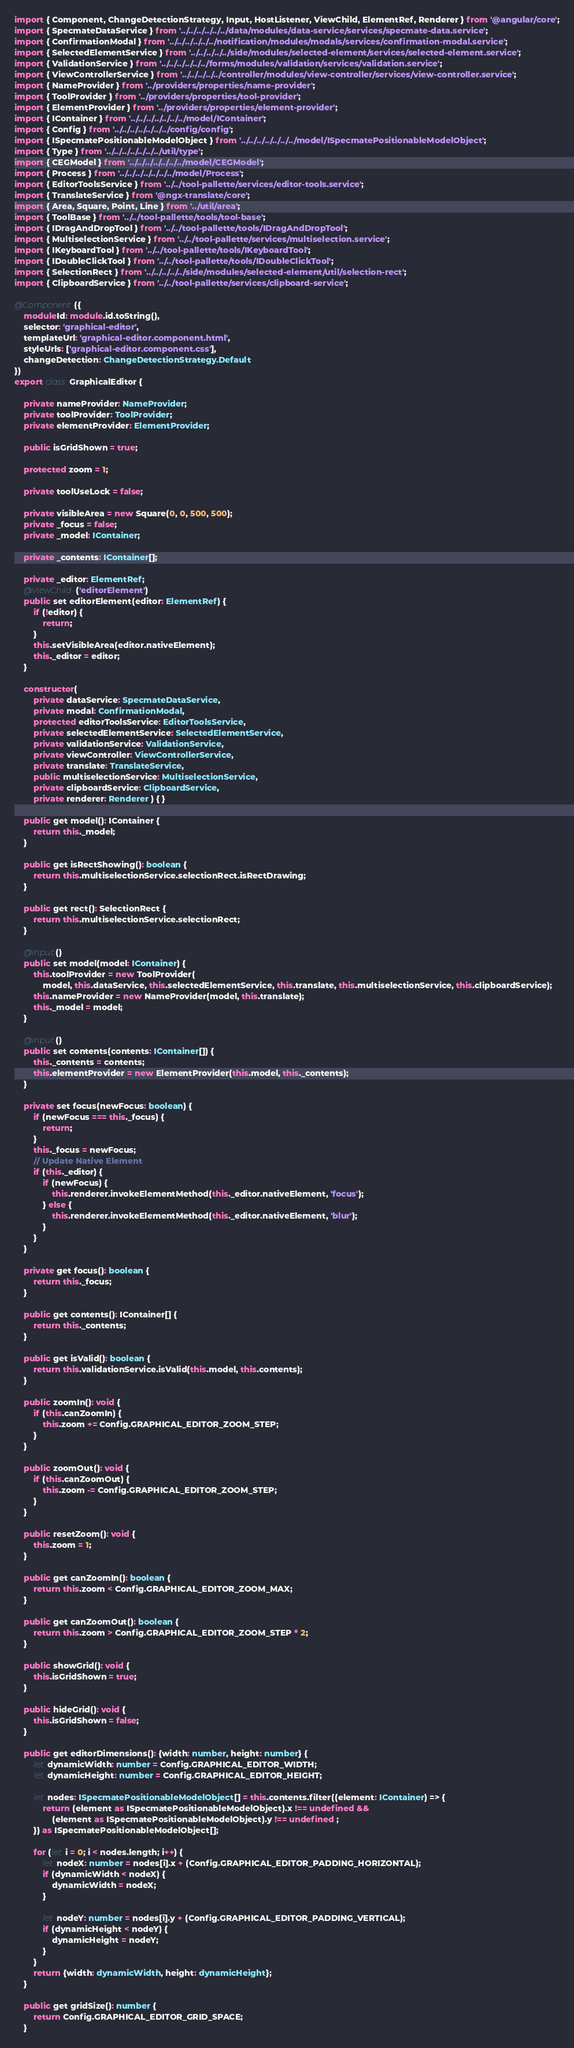<code> <loc_0><loc_0><loc_500><loc_500><_TypeScript_>import { Component, ChangeDetectionStrategy, Input, HostListener, ViewChild, ElementRef, Renderer } from '@angular/core';
import { SpecmateDataService } from '../../../../../../data/modules/data-service/services/specmate-data.service';
import { ConfirmationModal } from '../../../../../../notification/modules/modals/services/confirmation-modal.service';
import { SelectedElementService } from '../../../../../side/modules/selected-element/services/selected-element.service';
import { ValidationService } from '../../../../../../forms/modules/validation/services/validation.service';
import { ViewControllerService } from '../../../../../controller/modules/view-controller/services/view-controller.service';
import { NameProvider } from '../providers/properties/name-provider';
import { ToolProvider } from '../providers/properties/tool-provider';
import { ElementProvider } from '../providers/properties/element-provider';
import { IContainer } from '../../../../../../../model/IContainer';
import { Config } from '../../../../../../../config/config';
import { ISpecmatePositionableModelObject } from '../../../../../../../model/ISpecmatePositionableModelObject';
import { Type } from '../../../../../../../util/type';
import { CEGModel } from '../../../../../../../model/CEGModel';
import { Process } from '../../../../../../../model/Process';
import { EditorToolsService } from '../../tool-pallette/services/editor-tools.service';
import { TranslateService } from '@ngx-translate/core';
import { Area, Square, Point, Line } from '../util/area';
import { ToolBase } from '../../tool-pallette/tools/tool-base';
import { IDragAndDropTool } from '../../tool-pallette/tools/IDragAndDropTool';
import { MultiselectionService } from '../../tool-pallette/services/multiselection.service';
import { IKeyboardTool } from '../../tool-pallette/tools/IKeyboardTool';
import { IDoubleClickTool } from '../../tool-pallette/tools/IDoubleClickTool';
import { SelectionRect } from '../../../../../side/modules/selected-element/util/selection-rect';
import { ClipboardService } from '../../tool-pallette/services/clipboard-service';

@Component({
    moduleId: module.id.toString(),
    selector: 'graphical-editor',
    templateUrl: 'graphical-editor.component.html',
    styleUrls: ['graphical-editor.component.css'],
    changeDetection: ChangeDetectionStrategy.Default
})
export class GraphicalEditor {

    private nameProvider: NameProvider;
    private toolProvider: ToolProvider;
    private elementProvider: ElementProvider;

    public isGridShown = true;

    protected zoom = 1;

    private toolUseLock = false;

    private visibleArea = new Square(0, 0, 500, 500);
    private _focus = false;
    private _model: IContainer;

    private _contents: IContainer[];

    private _editor: ElementRef;
    @ViewChild('editorElement')
    public set editorElement(editor: ElementRef) {
        if (!editor) {
            return;
        }
        this.setVisibleArea(editor.nativeElement);
        this._editor = editor;
    }

    constructor(
        private dataService: SpecmateDataService,
        private modal: ConfirmationModal,
        protected editorToolsService: EditorToolsService,
        private selectedElementService: SelectedElementService,
        private validationService: ValidationService,
        private viewController: ViewControllerService,
        private translate: TranslateService,
        public multiselectionService: MultiselectionService,
        private clipboardService: ClipboardService,
        private renderer: Renderer ) { }

    public get model(): IContainer {
        return this._model;
    }

    public get isRectShowing(): boolean {
        return this.multiselectionService.selectionRect.isRectDrawing;
    }

    public get rect(): SelectionRect {
        return this.multiselectionService.selectionRect;
    }

    @Input()
    public set model(model: IContainer) {
        this.toolProvider = new ToolProvider(
            model, this.dataService, this.selectedElementService, this.translate, this.multiselectionService, this.clipboardService);
        this.nameProvider = new NameProvider(model, this.translate);
        this._model = model;
    }

    @Input()
    public set contents(contents: IContainer[]) {
        this._contents = contents;
        this.elementProvider = new ElementProvider(this.model, this._contents);
    }

    private set focus(newFocus: boolean) {
        if (newFocus === this._focus) {
            return;
        }
        this._focus = newFocus;
        // Update Native Element
        if (this._editor) {
            if (newFocus) {
                this.renderer.invokeElementMethod(this._editor.nativeElement, 'focus');
            } else {
                this.renderer.invokeElementMethod(this._editor.nativeElement, 'blur');
            }
        }
    }

    private get focus(): boolean {
        return this._focus;
    }

    public get contents(): IContainer[] {
        return this._contents;
    }

    public get isValid(): boolean {
        return this.validationService.isValid(this.model, this.contents);
    }

    public zoomIn(): void {
        if (this.canZoomIn) {
            this.zoom += Config.GRAPHICAL_EDITOR_ZOOM_STEP;
        }
    }

    public zoomOut(): void {
        if (this.canZoomOut) {
            this.zoom -= Config.GRAPHICAL_EDITOR_ZOOM_STEP;
        }
    }

    public resetZoom(): void {
        this.zoom = 1;
    }

    public get canZoomIn(): boolean {
        return this.zoom < Config.GRAPHICAL_EDITOR_ZOOM_MAX;
    }

    public get canZoomOut(): boolean {
        return this.zoom > Config.GRAPHICAL_EDITOR_ZOOM_STEP * 2;
    }

    public showGrid(): void {
        this.isGridShown = true;
    }

    public hideGrid(): void {
        this.isGridShown = false;
    }

    public get editorDimensions(): {width: number, height: number} {
        let dynamicWidth: number = Config.GRAPHICAL_EDITOR_WIDTH;
        let dynamicHeight: number = Config.GRAPHICAL_EDITOR_HEIGHT;

        let nodes: ISpecmatePositionableModelObject[] = this.contents.filter((element: IContainer) => {
            return (element as ISpecmatePositionableModelObject).x !== undefined &&
                (element as ISpecmatePositionableModelObject).y !== undefined ;
        }) as ISpecmatePositionableModelObject[];

        for (let i = 0; i < nodes.length; i++) {
            let nodeX: number = nodes[i].x + (Config.GRAPHICAL_EDITOR_PADDING_HORIZONTAL);
            if (dynamicWidth < nodeX) {
                dynamicWidth = nodeX;
            }

            let nodeY: number = nodes[i].y + (Config.GRAPHICAL_EDITOR_PADDING_VERTICAL);
            if (dynamicHeight < nodeY) {
                dynamicHeight = nodeY;
            }
        }
        return {width: dynamicWidth, height: dynamicHeight};
    }

    public get gridSize(): number {
        return Config.GRAPHICAL_EDITOR_GRID_SPACE;
    }
</code> 